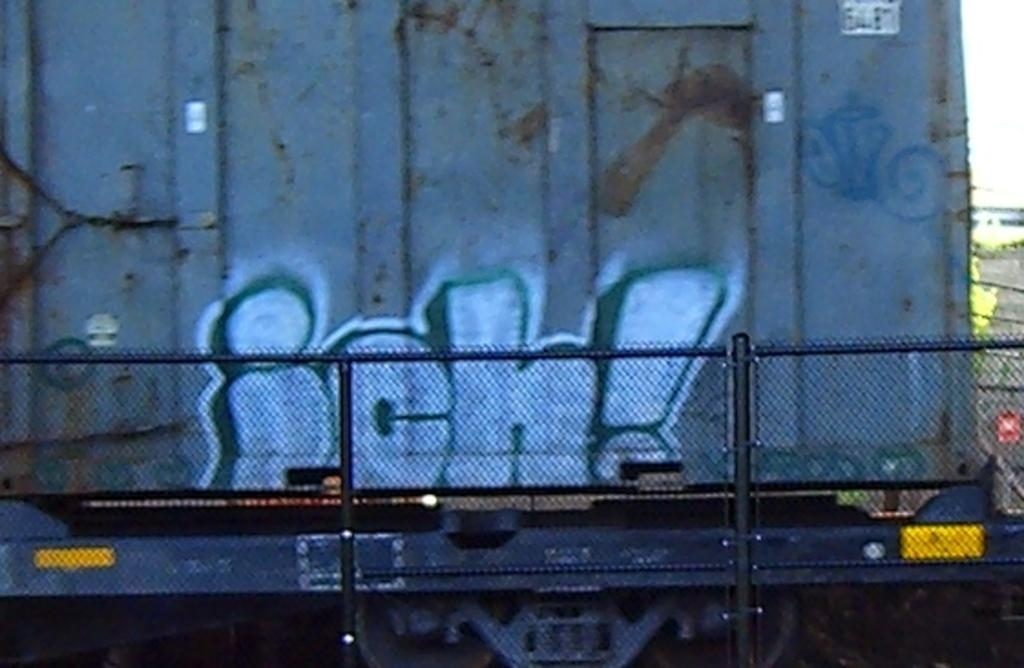<image>
Present a compact description of the photo's key features. Some graffiti on a building or train car that reads ich! 